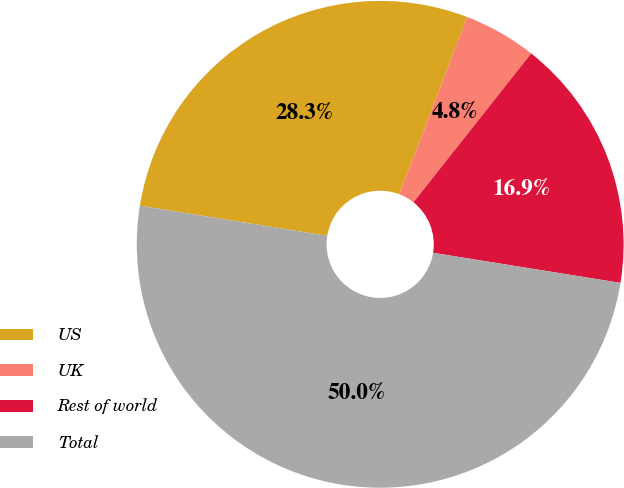<chart> <loc_0><loc_0><loc_500><loc_500><pie_chart><fcel>US<fcel>UK<fcel>Rest of world<fcel>Total<nl><fcel>28.29%<fcel>4.83%<fcel>16.88%<fcel>50.0%<nl></chart> 